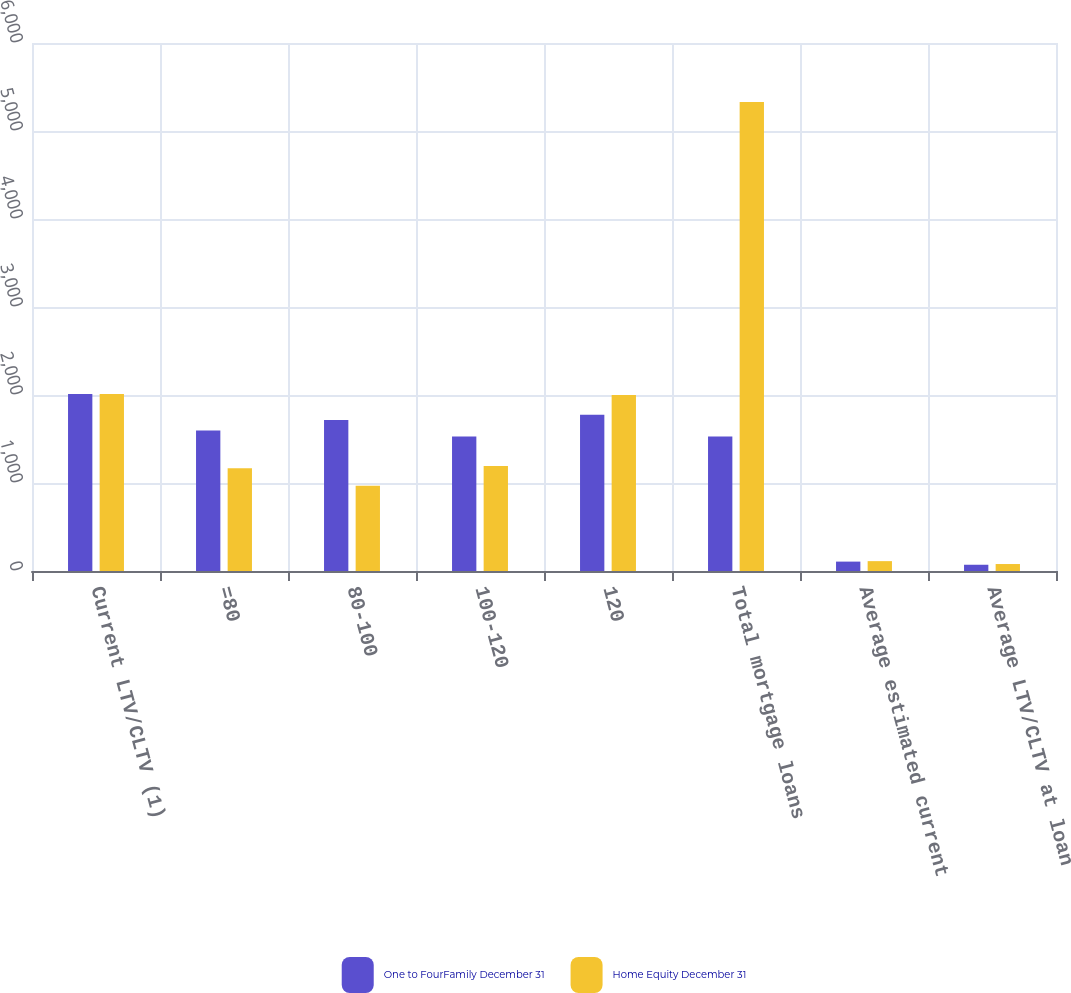Convert chart to OTSL. <chart><loc_0><loc_0><loc_500><loc_500><stacked_bar_chart><ecel><fcel>Current LTV/CLTV (1)<fcel>=80<fcel>80-100<fcel>100-120<fcel>120<fcel>Total mortgage loans<fcel>Average estimated current<fcel>Average LTV/CLTV at loan<nl><fcel>One to FourFamily December 31<fcel>2011<fcel>1596.3<fcel>1716.8<fcel>1527.3<fcel>1775.4<fcel>1527.3<fcel>106.7<fcel>71<nl><fcel>Home Equity December 31<fcel>2011<fcel>1168.9<fcel>967.9<fcel>1191.9<fcel>2000<fcel>5328.7<fcel>112.1<fcel>79.2<nl></chart> 